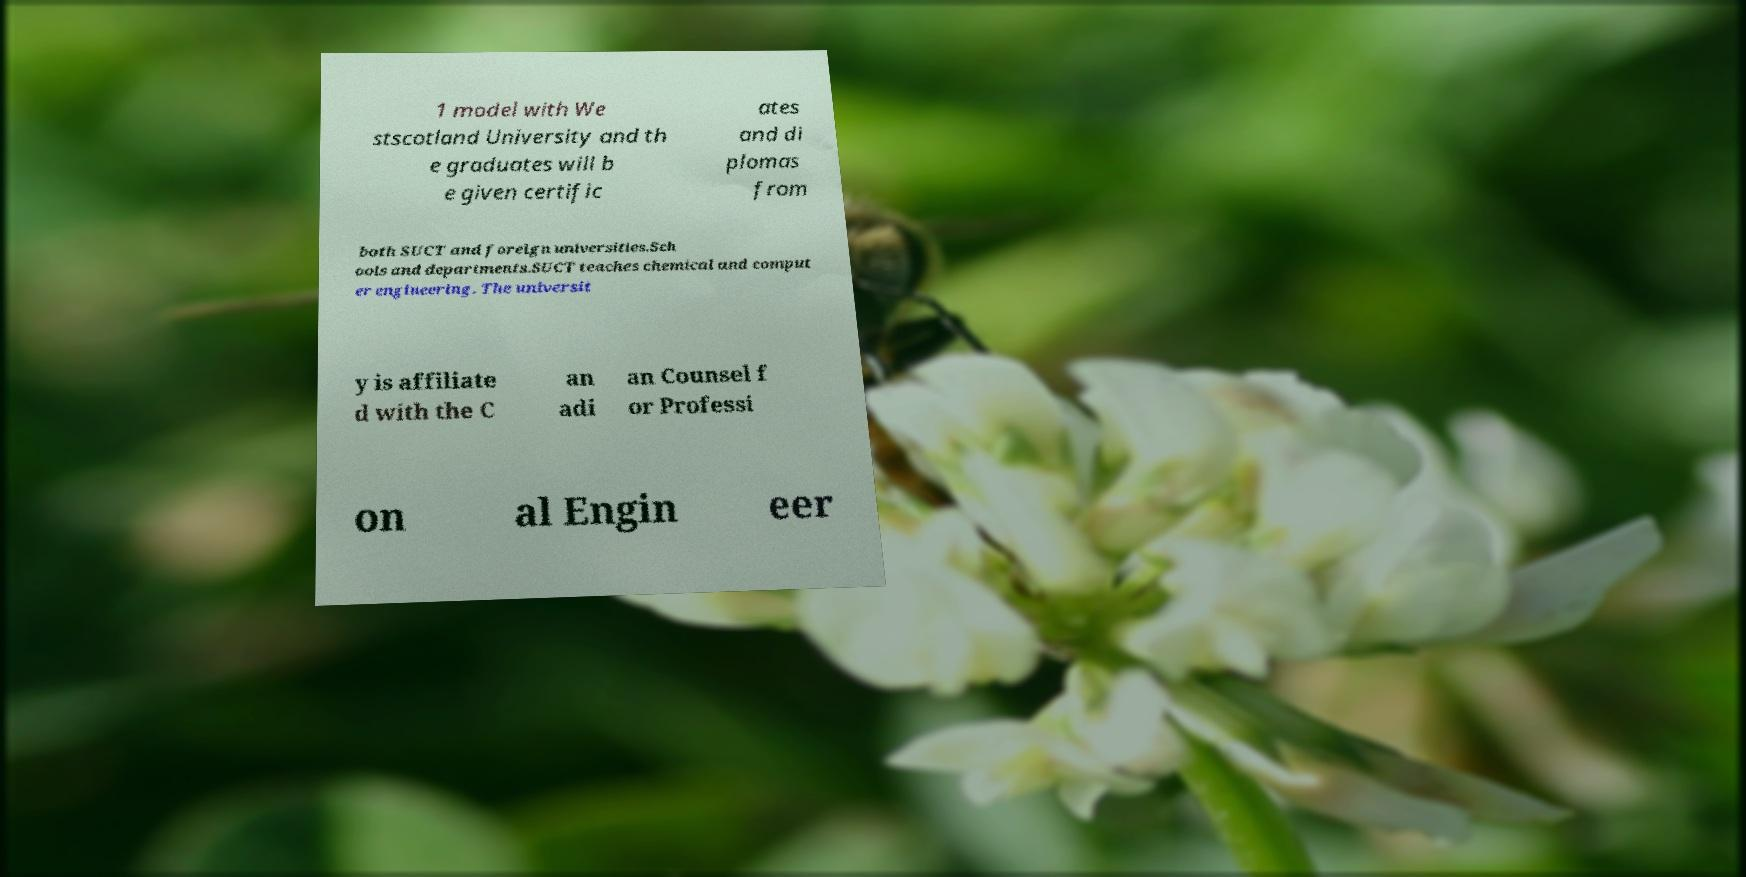Can you read and provide the text displayed in the image?This photo seems to have some interesting text. Can you extract and type it out for me? 1 model with We stscotland University and th e graduates will b e given certific ates and di plomas from both SUCT and foreign universities.Sch ools and departments.SUCT teaches chemical and comput er engineering. The universit y is affiliate d with the C an adi an Counsel f or Professi on al Engin eer 